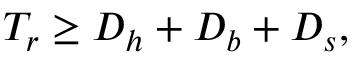<formula> <loc_0><loc_0><loc_500><loc_500>T _ { r } \geq D _ { h } + D _ { b } + D _ { s } ,</formula> 